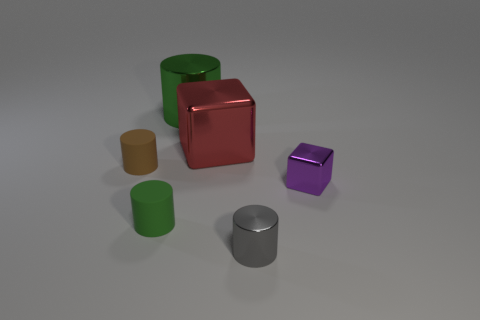How many purple metal blocks are on the right side of the metallic block that is on the right side of the cylinder that is in front of the tiny green thing?
Your response must be concise. 0. What is the material of the cylinder that is both behind the purple metal object and right of the tiny brown cylinder?
Make the answer very short. Metal. Is the material of the gray cylinder the same as the green object that is in front of the large green cylinder?
Your answer should be compact. No. Is the number of tiny brown matte cylinders in front of the tiny gray thing greater than the number of tiny metal cylinders that are on the left side of the large shiny cylinder?
Offer a very short reply. No. The tiny gray object has what shape?
Give a very brief answer. Cylinder. Does the green object that is in front of the small purple shiny cube have the same material as the large cube that is to the left of the tiny cube?
Give a very brief answer. No. What is the shape of the tiny metal thing that is behind the small shiny cylinder?
Keep it short and to the point. Cube. The red object that is the same shape as the small purple object is what size?
Offer a terse response. Large. Does the large metallic block have the same color as the tiny cube?
Provide a short and direct response. No. Is there any other thing that is the same shape as the brown object?
Your answer should be compact. Yes. 